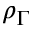<formula> <loc_0><loc_0><loc_500><loc_500>\rho _ { \Gamma }</formula> 